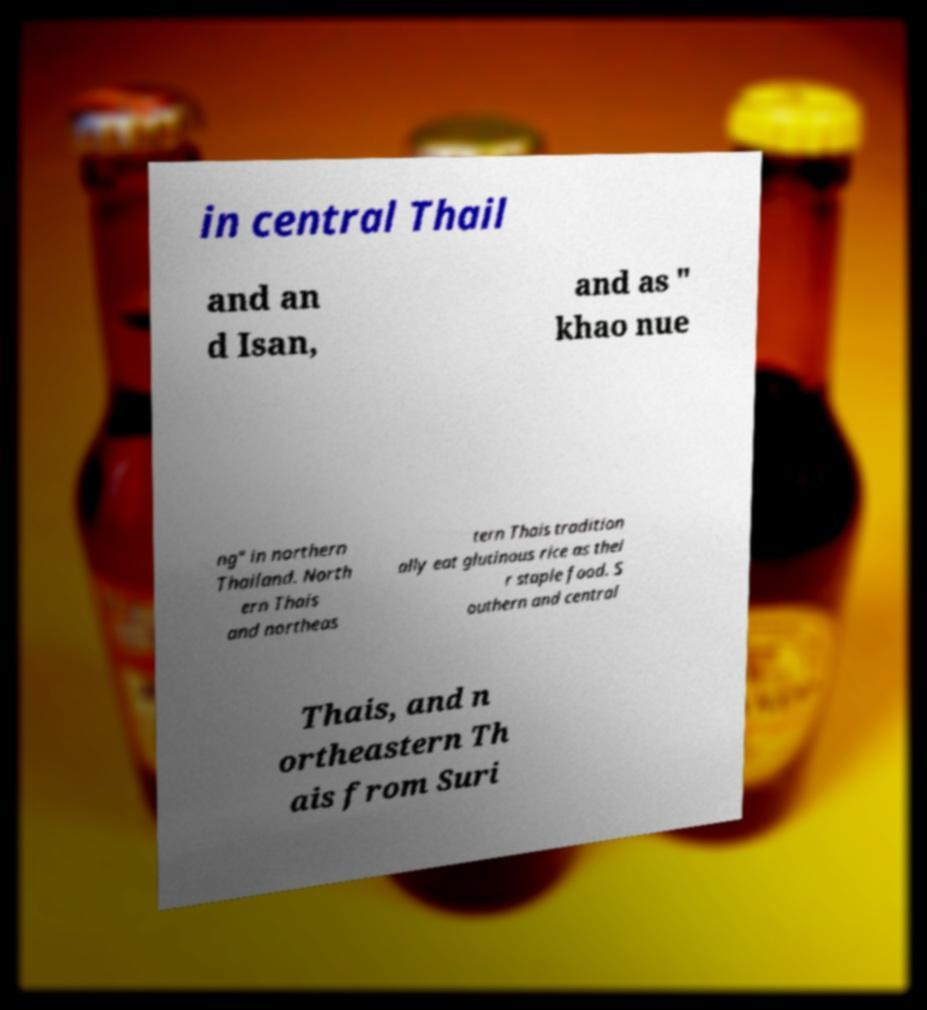I need the written content from this picture converted into text. Can you do that? in central Thail and an d Isan, and as " khao nue ng" in northern Thailand. North ern Thais and northeas tern Thais tradition ally eat glutinous rice as thei r staple food. S outhern and central Thais, and n ortheastern Th ais from Suri 